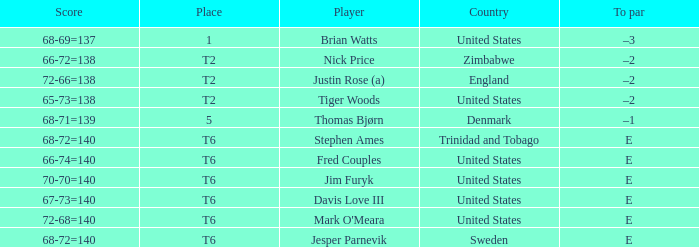In what place was Tiger Woods of the United States? T2. Would you be able to parse every entry in this table? {'header': ['Score', 'Place', 'Player', 'Country', 'To par'], 'rows': [['68-69=137', '1', 'Brian Watts', 'United States', '–3'], ['66-72=138', 'T2', 'Nick Price', 'Zimbabwe', '–2'], ['72-66=138', 'T2', 'Justin Rose (a)', 'England', '–2'], ['65-73=138', 'T2', 'Tiger Woods', 'United States', '–2'], ['68-71=139', '5', 'Thomas Bjørn', 'Denmark', '–1'], ['68-72=140', 'T6', 'Stephen Ames', 'Trinidad and Tobago', 'E'], ['66-74=140', 'T6', 'Fred Couples', 'United States', 'E'], ['70-70=140', 'T6', 'Jim Furyk', 'United States', 'E'], ['67-73=140', 'T6', 'Davis Love III', 'United States', 'E'], ['72-68=140', 'T6', "Mark O'Meara", 'United States', 'E'], ['68-72=140', 'T6', 'Jesper Parnevik', 'Sweden', 'E']]} 